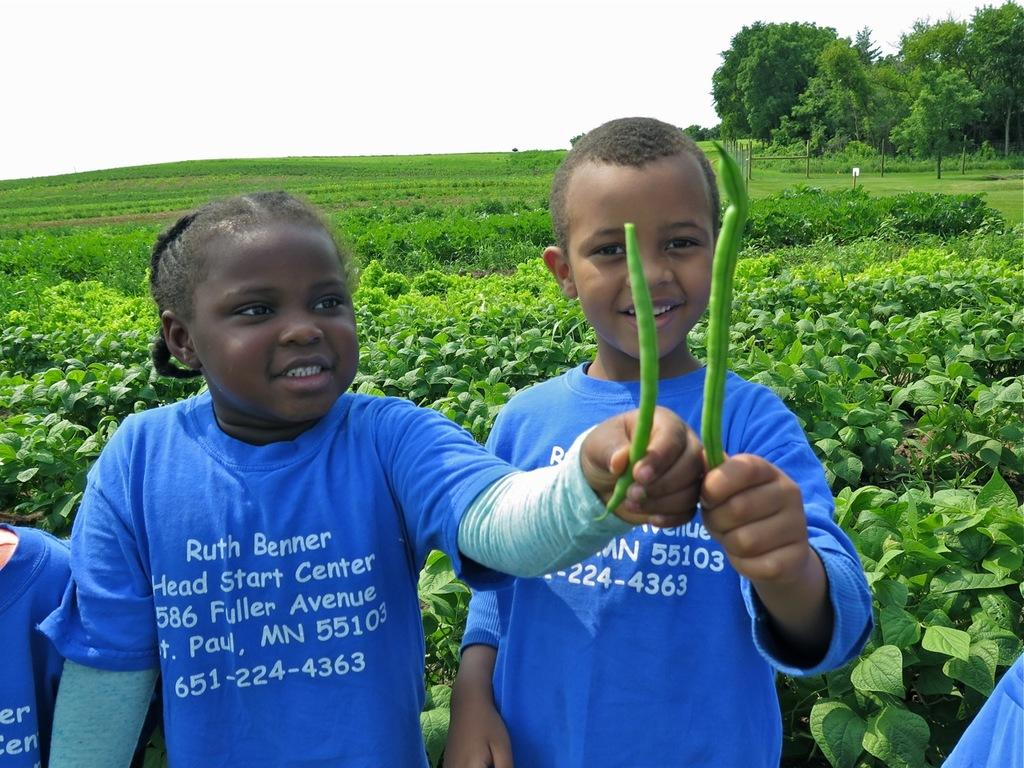How many children are present in the image? There are two children in the image. What are the children holding in their hands? The children are holding vegetables in their hands. What type of vegetation can be seen in the image? There are plants, grass, and trees in the image. What is visible in the background of the image? The sky is visible in the background of the image. What type of care or guide is the child holding in their hands? The children are not holding any care or guide in their hands; they are holding vegetables. 